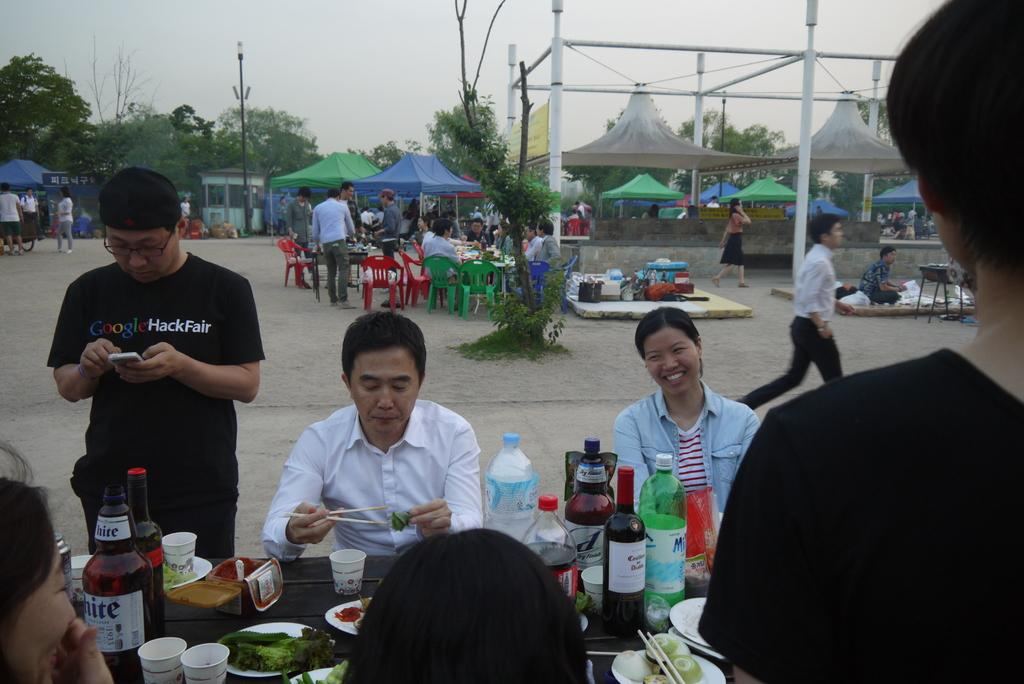How many people are in the group visible in the image? There is a group of people in the image, but the exact number cannot be determined from the provided facts. What objects are on the table in the image? There is a bottle, a cup, a plate, and food on the table in the image. What is the natural element visible at the back side of the image? There is a tree visible at the back side of the image. What type of temporary shelter is visible at the back side of the image? There are tents visible at the back side of the image. What type of drum is being played by the government in the image? There is no drum or government present in the image. 